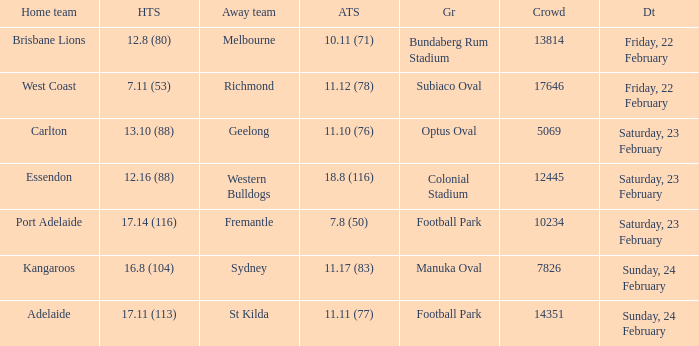What score did the away team receive against home team Port Adelaide? 7.8 (50). 